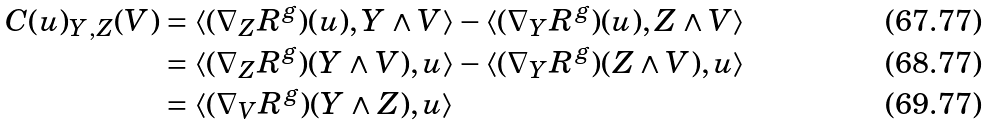<formula> <loc_0><loc_0><loc_500><loc_500>C ( u ) _ { Y , Z } ( V ) & = \langle ( \nabla _ { Z } R ^ { g } ) ( u ) , Y \wedge V \rangle - \langle ( \nabla _ { Y } R ^ { g } ) ( u ) , Z \wedge V \rangle \\ & = \langle ( \nabla _ { Z } R ^ { g } ) ( Y \wedge V ) , u \rangle - \langle ( \nabla _ { Y } R ^ { g } ) ( Z \wedge V ) , u \rangle \\ & = \langle ( \nabla _ { V } R ^ { g } ) ( Y \wedge Z ) , u \rangle</formula> 